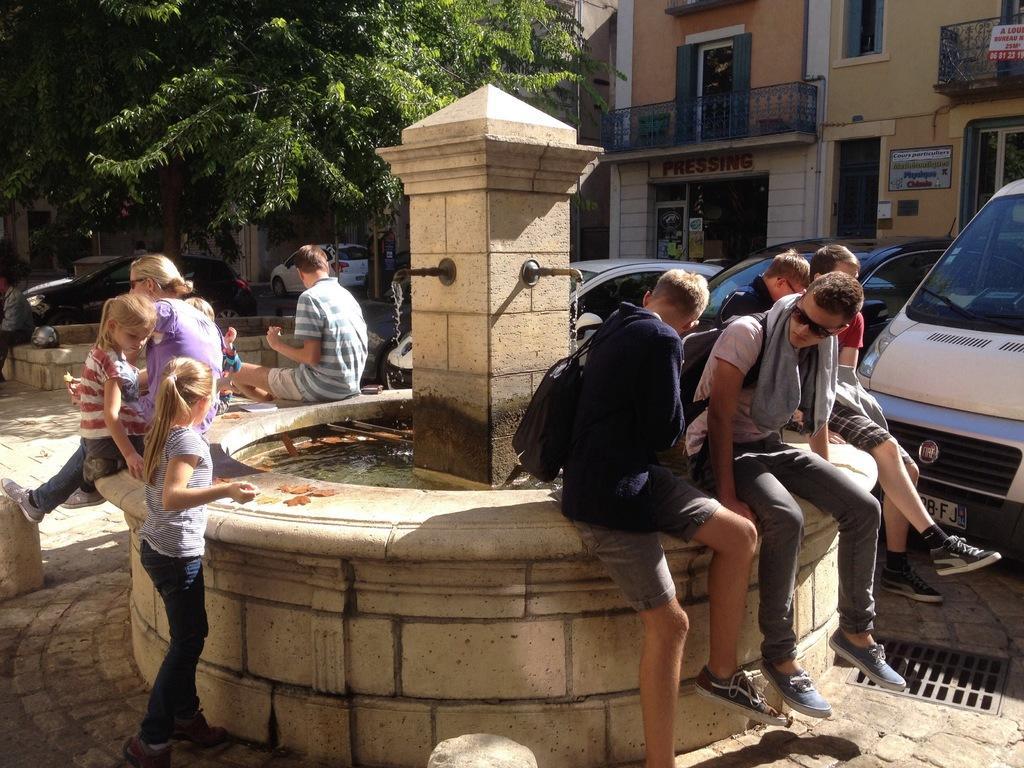Please provide a concise description of this image. In this picture there is a group of boys sitting on the brown color water tank. Beside there is a woman wearing purple color t-shirt and two small girls standing and playing with the water. Behind there is a brown color building and some shops. In the background we can see many trees. 